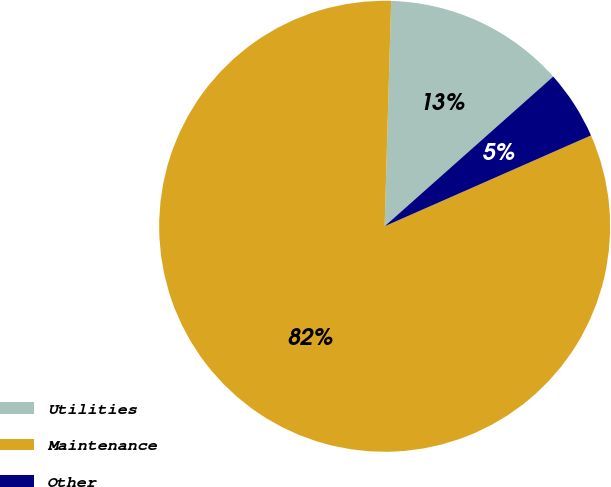<chart> <loc_0><loc_0><loc_500><loc_500><pie_chart><fcel>Utilities<fcel>Maintenance<fcel>Other<nl><fcel>12.98%<fcel>82.07%<fcel>4.96%<nl></chart> 